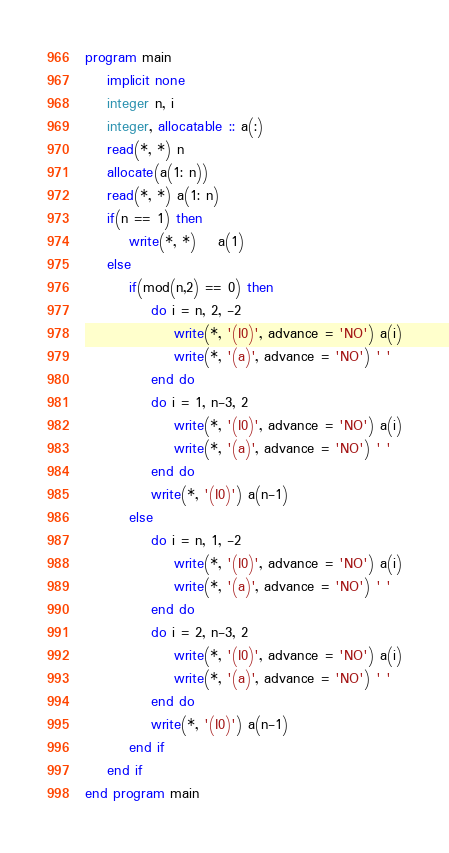Convert code to text. <code><loc_0><loc_0><loc_500><loc_500><_FORTRAN_>program main
	implicit none
	integer n, i
	integer, allocatable :: a(:)
	read(*, *) n
	allocate(a(1: n))
	read(*, *) a(1: n)
	if(n == 1) then
		write(*, *)	a(1)
	else
		if(mod(n,2) == 0) then
			do i = n, 2, -2
				write(*, '(I0)', advance = 'NO') a(i)
				write(*, '(a)', advance = 'NO') ' '
			end do
			do i = 1, n-3, 2
				write(*, '(I0)', advance = 'NO') a(i)
				write(*, '(a)', advance = 'NO') ' '
			end do
			write(*, '(I0)') a(n-1)
		else
			do i = n, 1, -2
				write(*, '(I0)', advance = 'NO') a(i)
				write(*, '(a)', advance = 'NO') ' '
			end do
			do i = 2, n-3, 2
				write(*, '(I0)', advance = 'NO') a(i)
				write(*, '(a)', advance = 'NO') ' '
			end do
			write(*, '(I0)') a(n-1)
		end if
	end if
end program main</code> 